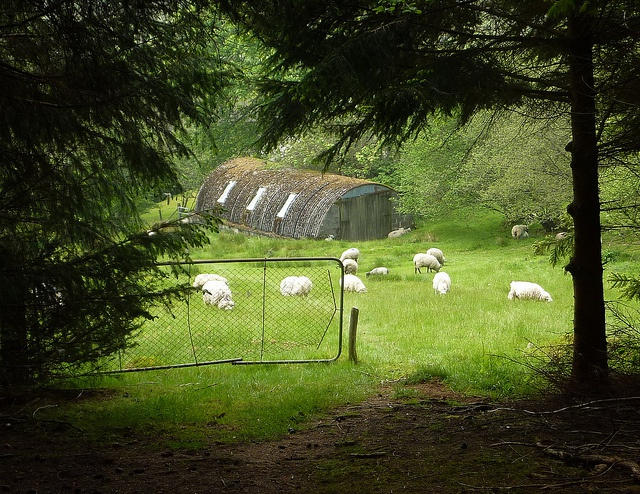Describe the objects in this image and their specific colors. I can see sheep in black, ivory, beige, olive, and darkgray tones, sheep in black, ivory, olive, and beige tones, sheep in black, ivory, beige, and tan tones, sheep in black, ivory, olive, beige, and khaki tones, and sheep in black, ivory, beige, olive, and darkgreen tones in this image. 